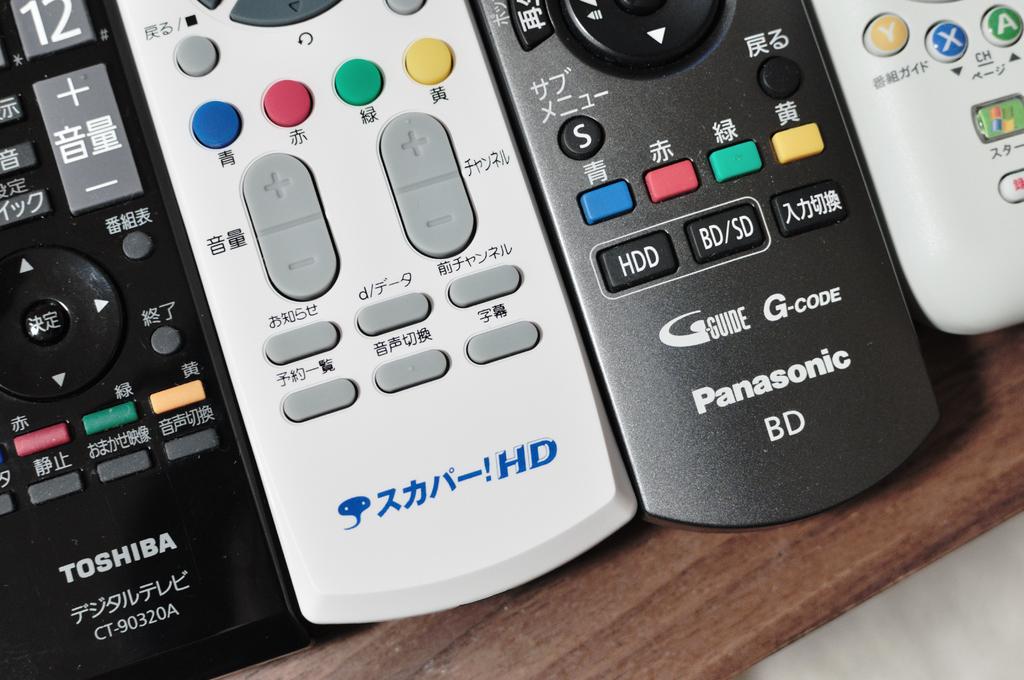What brand are these remote controllers?
Offer a very short reply. Panasonic and toshiba. What button is on the bottom of the black controller on the left?
Your answer should be very brief. Unanswerable. 